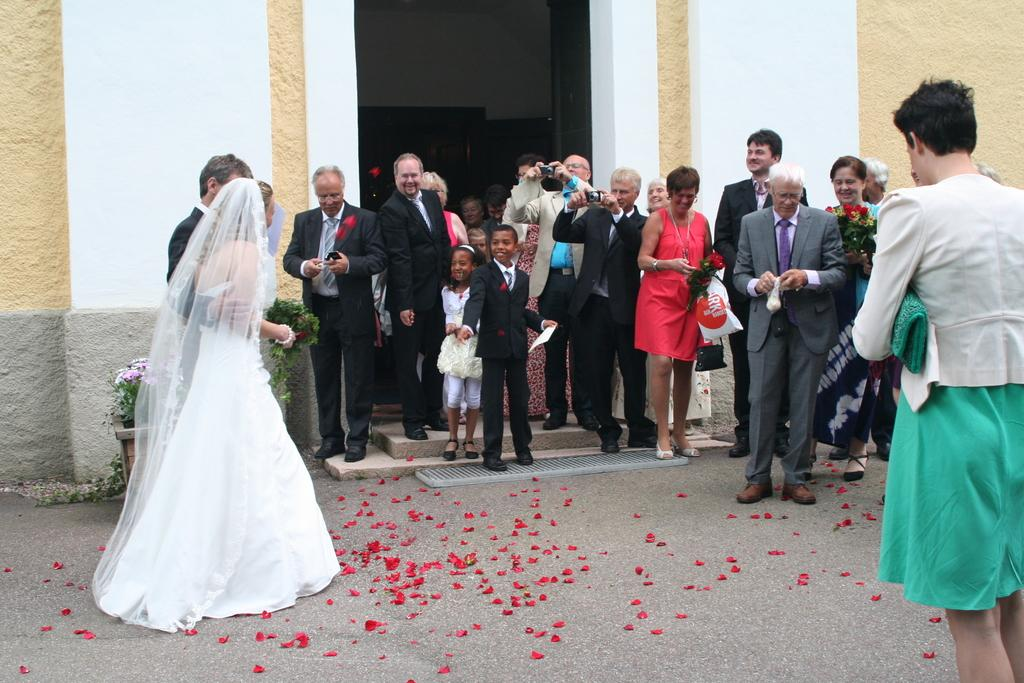What can be seen in the image involving living organisms? There are people standing in the image, and there are flowers and a plant present. What type of structure is visible in the image? There is a wall in the image. What type of tin can be seen in the image? There is no tin present in the image. What is the weather like in the image? The provided facts do not mention the weather, so it cannot be determined from the image. 